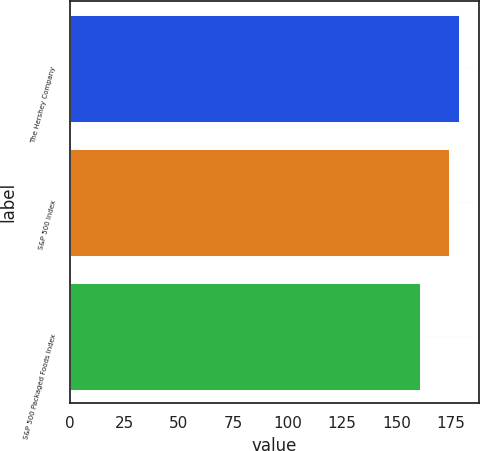Convert chart. <chart><loc_0><loc_0><loc_500><loc_500><bar_chart><fcel>The Hershey Company<fcel>S&P 500 Index<fcel>S&P 500 Packaged Foods Index<nl><fcel>179<fcel>174<fcel>161<nl></chart> 